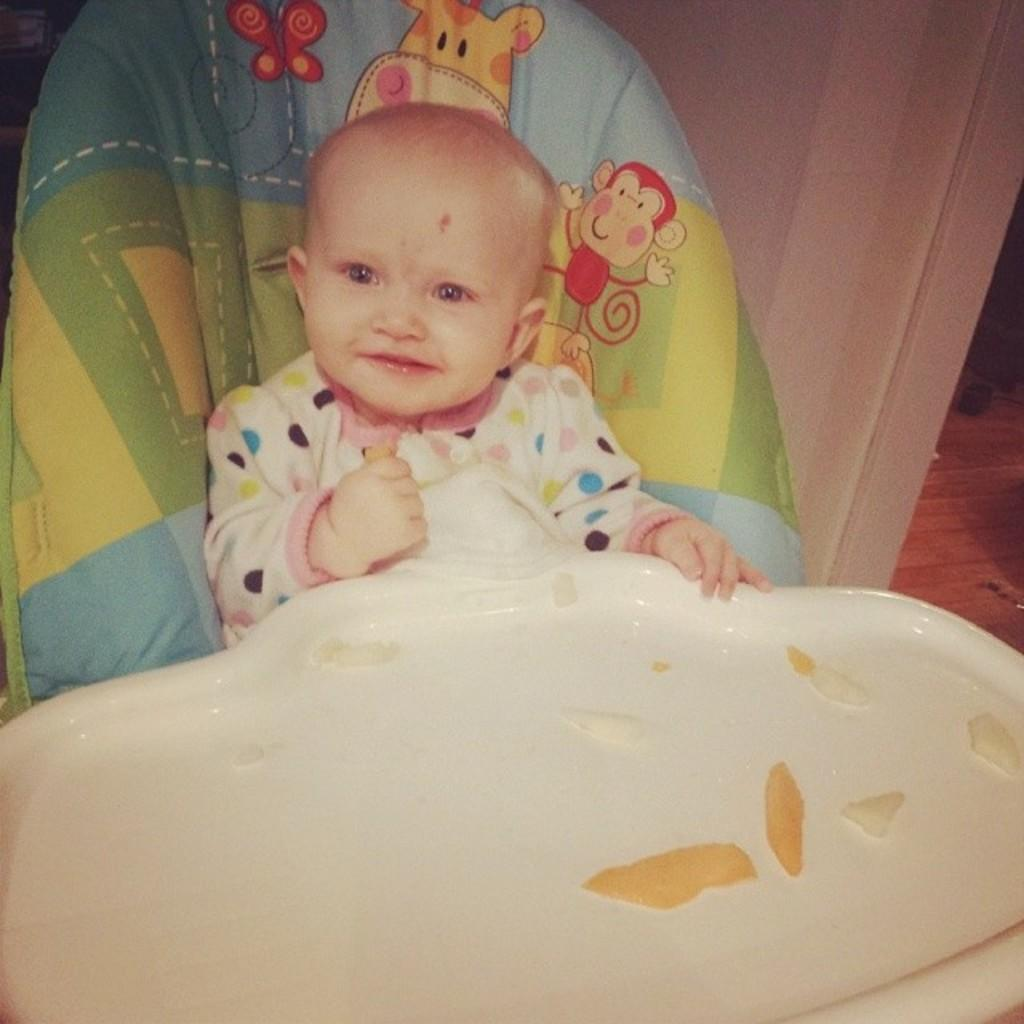What is the main subject of the image? There is a baby in the image. How is the baby positioned in the image? The baby is seated in a chair. What other object can be seen in the image? There is a table in the image. What is on the table? There are pieces on the table. Can you tell me how many planes are flying over the baby in the image? There are no planes visible in the image; it only features a baby seated in a chair, a table, and pieces on the table. Is there a party happening in the image? There is no indication of a party in the image; it simply shows a baby seated in a chair with a table and pieces on it. 